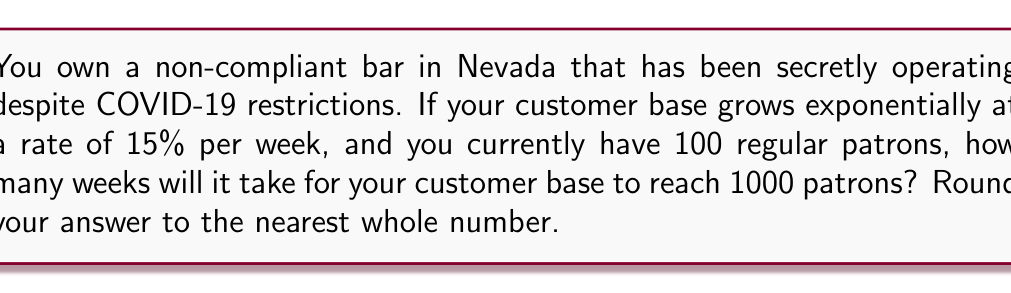Provide a solution to this math problem. Let's approach this step-by-step using an exponential model and logarithms:

1) The exponential growth model is given by:
   $A = P(1 + r)^t$
   Where:
   $A$ is the final amount
   $P$ is the initial amount
   $r$ is the growth rate
   $t$ is the time

2) In this case:
   $P = 100$ (initial patrons)
   $r = 0.15$ (15% growth rate)
   $A = 1000$ (final number of patrons)
   We need to solve for $t$ (number of weeks)

3) Substituting these values into the equation:
   $1000 = 100(1 + 0.15)^t$

4) Simplify:
   $1000 = 100(1.15)^t$

5) Divide both sides by 100:
   $10 = (1.15)^t$

6) Now we can use logarithms to solve for $t$. Taking the natural log of both sides:
   $\ln(10) = \ln((1.15)^t)$

7) Using the logarithm property $\ln(a^b) = b\ln(a)$:
   $\ln(10) = t\ln(1.15)$

8) Solve for $t$:
   $t = \frac{\ln(10)}{\ln(1.15)}$

9) Calculate:
   $t \approx 16.27$ weeks

10) Rounding to the nearest whole number:
    $t = 16$ weeks
Answer: 16 weeks 